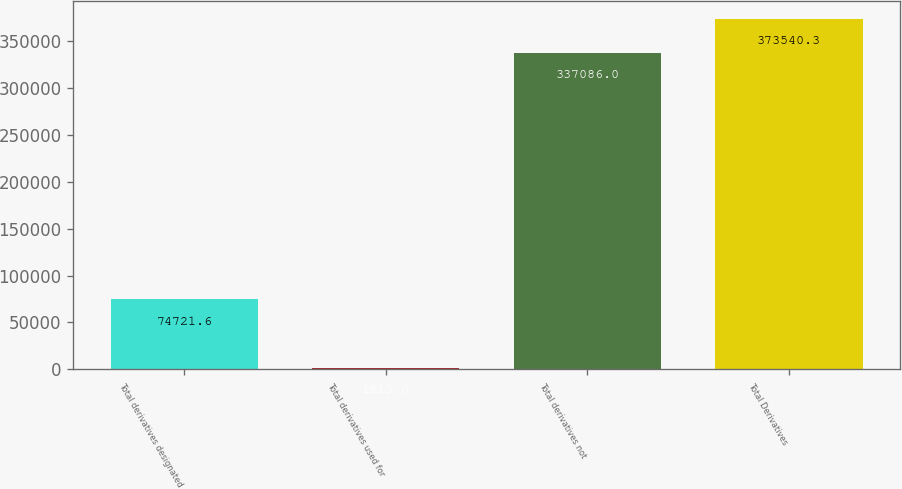Convert chart. <chart><loc_0><loc_0><loc_500><loc_500><bar_chart><fcel>Total derivatives designated<fcel>Total derivatives used for<fcel>Total derivatives not<fcel>Total Derivatives<nl><fcel>74721.6<fcel>1813<fcel>337086<fcel>373540<nl></chart> 